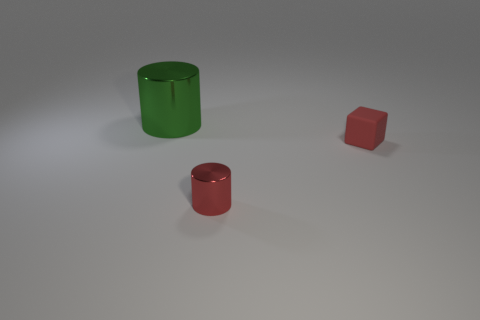How many blocks are behind the metal cylinder behind the red metal thing?
Your answer should be compact. 0. What number of things are either small metal cylinders or small red rubber things?
Provide a short and direct response. 2. Is the large shiny thing the same shape as the small metallic object?
Offer a terse response. Yes. What material is the tiny red cube?
Provide a succinct answer. Rubber. What number of metallic cylinders are in front of the big green shiny cylinder and behind the red shiny thing?
Provide a short and direct response. 0. Is the red cylinder the same size as the rubber cube?
Offer a very short reply. Yes. Do the cylinder that is in front of the green metallic object and the large green cylinder have the same size?
Your answer should be very brief. No. The metallic cylinder that is in front of the tiny rubber object is what color?
Ensure brevity in your answer.  Red. How many red matte cubes are there?
Offer a very short reply. 1. What shape is the large green object that is made of the same material as the small red cylinder?
Make the answer very short. Cylinder. 